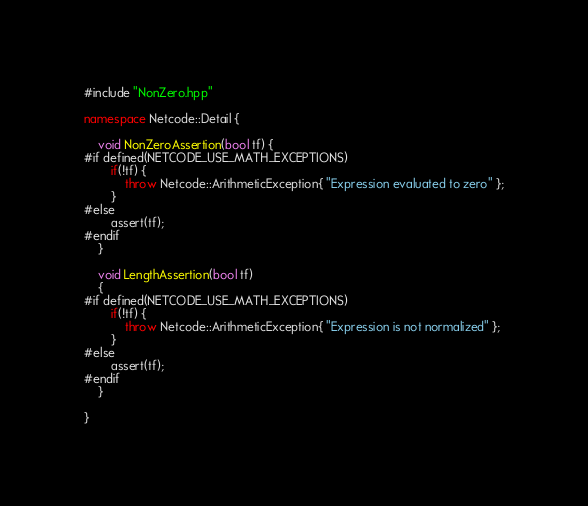Convert code to text. <code><loc_0><loc_0><loc_500><loc_500><_C++_>#include "NonZero.hpp"

namespace Netcode::Detail {

	void NonZeroAssertion(bool tf) {
#if defined(NETCODE_USE_MATH_EXCEPTIONS)
		if(!tf) {
			throw Netcode::ArithmeticException{ "Expression evaluated to zero" };
		}
#else
		assert(tf);
#endif
	}

	void LengthAssertion(bool tf)
	{
#if defined(NETCODE_USE_MATH_EXCEPTIONS)
		if(!tf) {
			throw Netcode::ArithmeticException{ "Expression is not normalized" };
		}
#else
		assert(tf);
#endif
	}

}
</code> 